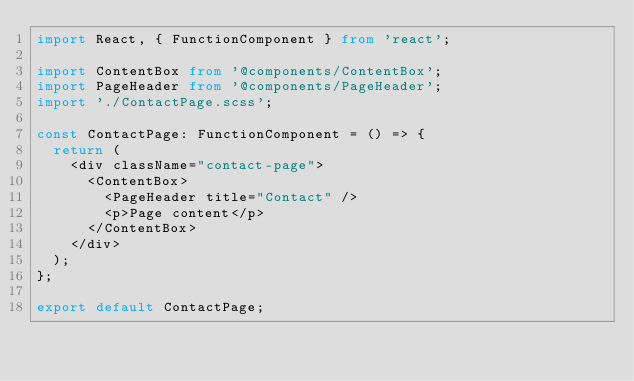<code> <loc_0><loc_0><loc_500><loc_500><_TypeScript_>import React, { FunctionComponent } from 'react';

import ContentBox from '@components/ContentBox';
import PageHeader from '@components/PageHeader';
import './ContactPage.scss';

const ContactPage: FunctionComponent = () => {
  return (
    <div className="contact-page">
      <ContentBox>
        <PageHeader title="Contact" />
        <p>Page content</p>
      </ContentBox>
    </div>
  );
};

export default ContactPage;
</code> 